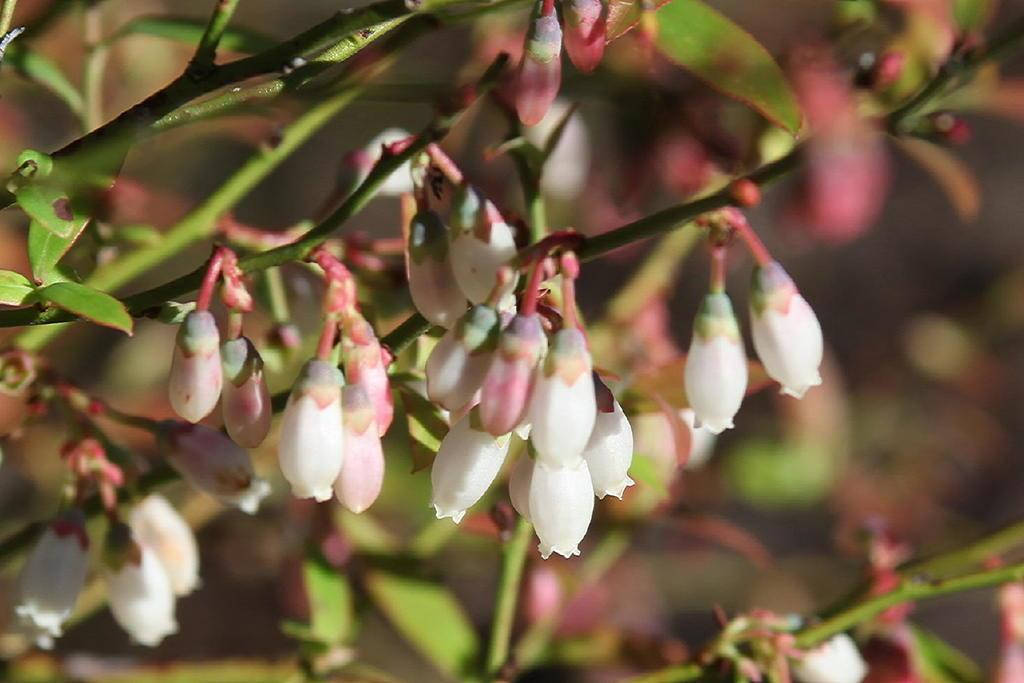What stage of growth are the plants in the image at? The plants in the image have flower buds, indicating that they are in the process of blooming. What other parts of the plants can be seen in the image? Leaves are visible in the image. Can you describe the background of the image? The background of the image is blurry. What type of juice is being extracted from the string in the image? There is no string or juice present in the image; it features plants with flower buds and leaves. 